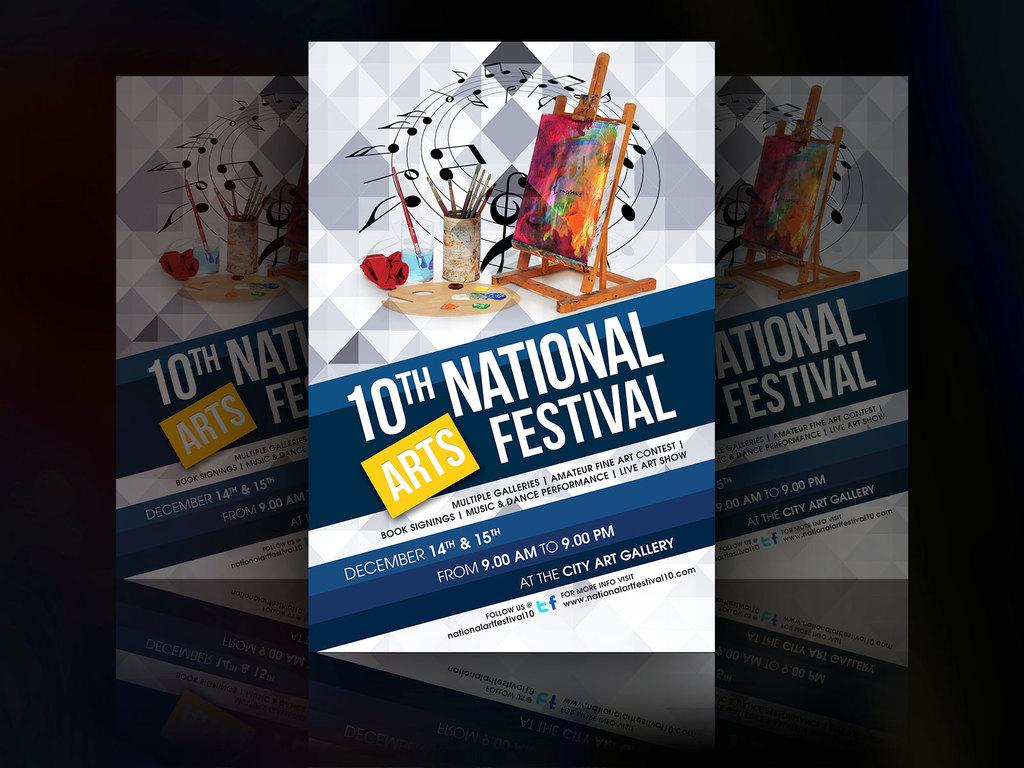<image>
Present a compact description of the photo's key features. A banner advertising the 10th National Arts Festival on December 14th and 15th at the City art gallery. 